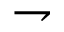<formula> <loc_0><loc_0><loc_500><loc_500>\rightharpoondown</formula> 